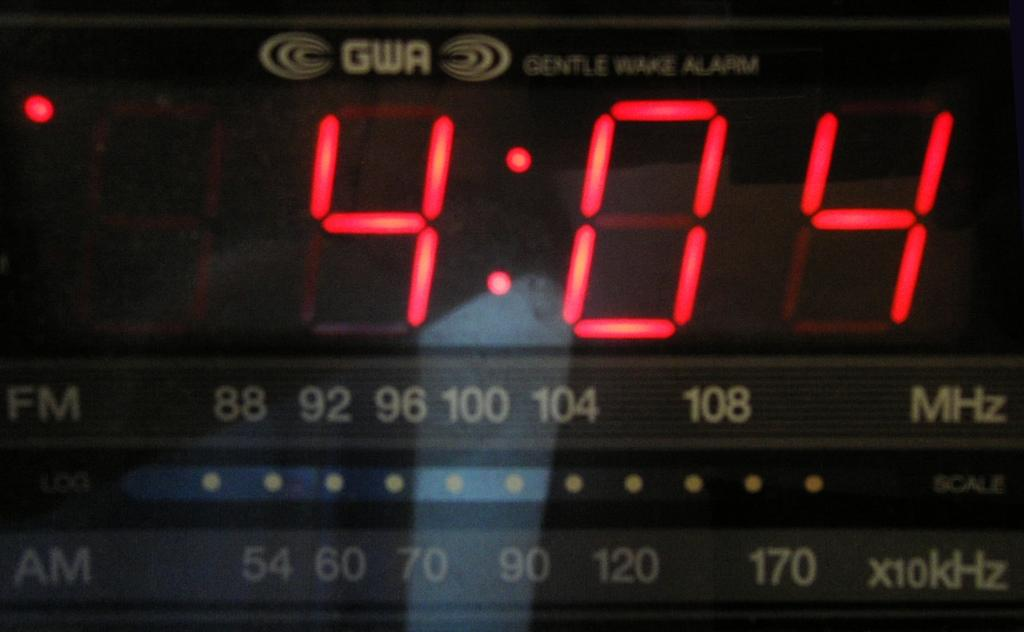<image>
Share a concise interpretation of the image provided. A digital clock with both FM and AM radio that reads the time as 4:04. 